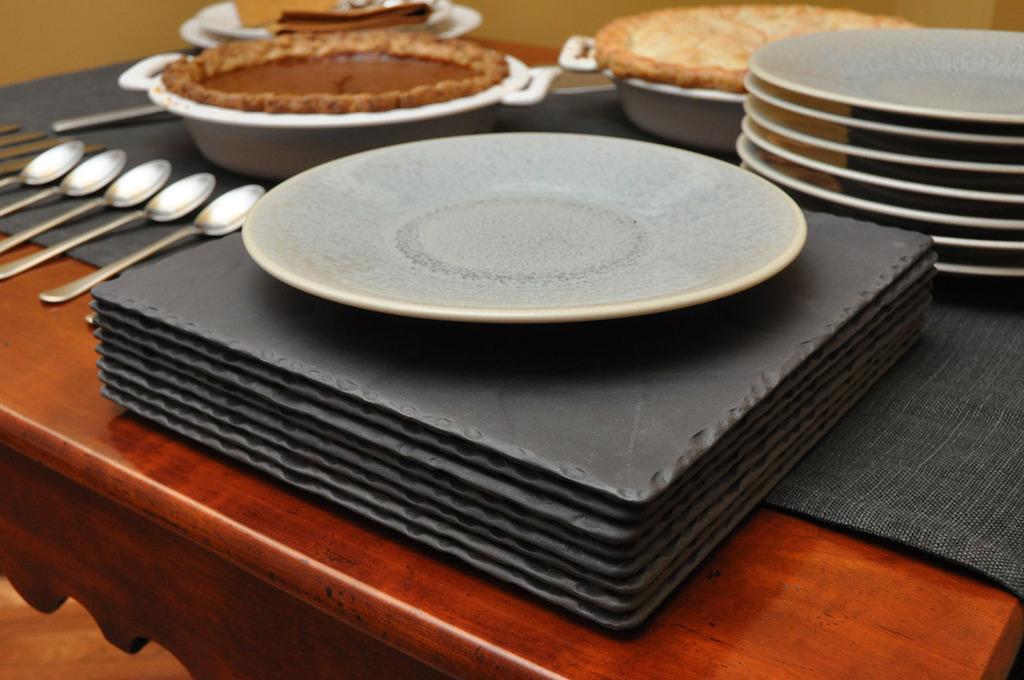How would you summarize this image in a sentence or two? There is a table which has some plates,spoons and eatables on it. 